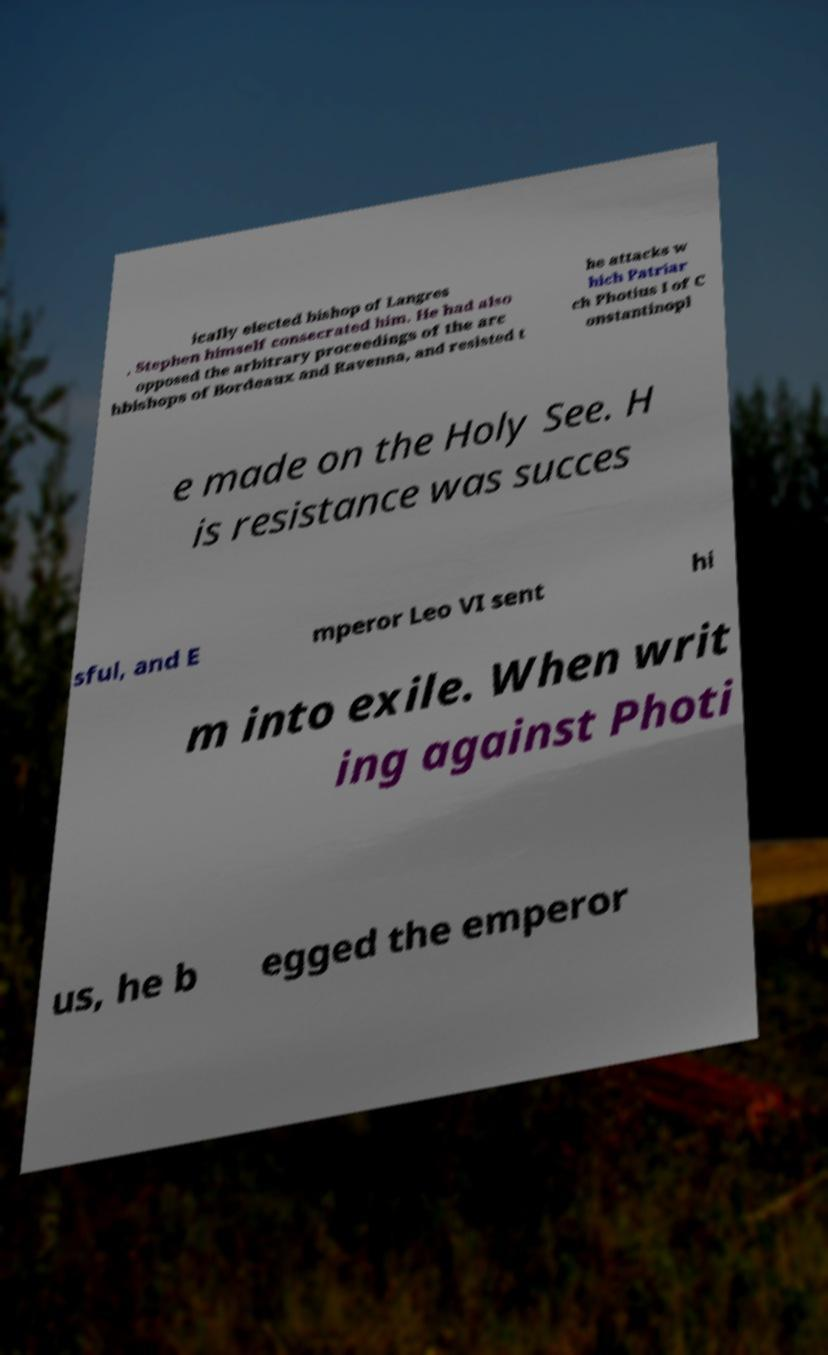For documentation purposes, I need the text within this image transcribed. Could you provide that? ically elected bishop of Langres , Stephen himself consecrated him. He had also opposed the arbitrary proceedings of the arc hbishops of Bordeaux and Ravenna, and resisted t he attacks w hich Patriar ch Photius I of C onstantinopl e made on the Holy See. H is resistance was succes sful, and E mperor Leo VI sent hi m into exile. When writ ing against Photi us, he b egged the emperor 